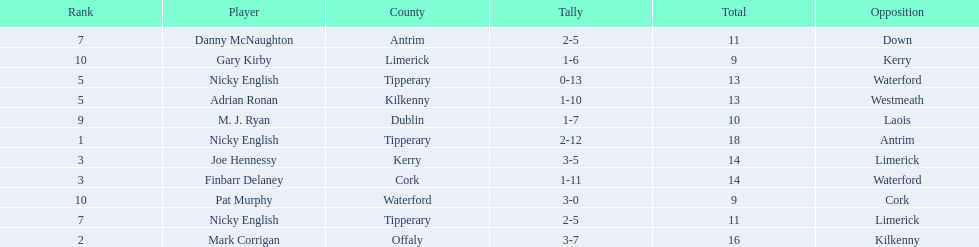What numbers are in the total column? 18, 16, 14, 14, 13, 13, 11, 11, 10, 9, 9. What row has the number 10 in the total column? 9, M. J. Ryan, Dublin, 1-7, 10, Laois. What name is in the player column for this row? M. J. Ryan. 